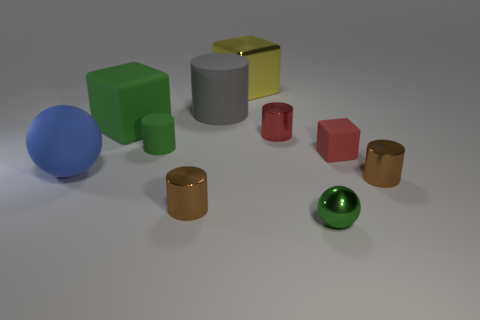There is a green thing that is both on the left side of the shiny sphere and in front of the large rubber block; what shape is it?
Offer a terse response. Cylinder. What material is the sphere left of the tiny metallic cylinder left of the large cylinder?
Provide a short and direct response. Rubber. Is the number of small red metal cylinders greater than the number of cubes?
Offer a very short reply. No. Is the tiny rubber cylinder the same color as the shiny sphere?
Give a very brief answer. Yes. There is a yellow block that is the same size as the blue rubber thing; what is it made of?
Provide a succinct answer. Metal. Are the green sphere and the blue thing made of the same material?
Your response must be concise. No. What number of big blue objects are made of the same material as the green cylinder?
Offer a terse response. 1. How many things are either cubes right of the yellow metal cube or small matte objects that are on the right side of the big yellow metallic thing?
Your answer should be very brief. 1. Are there more green objects that are behind the metallic ball than tiny red things right of the small matte cylinder?
Your answer should be very brief. No. There is a tiny matte thing that is behind the red block; what color is it?
Offer a terse response. Green. 